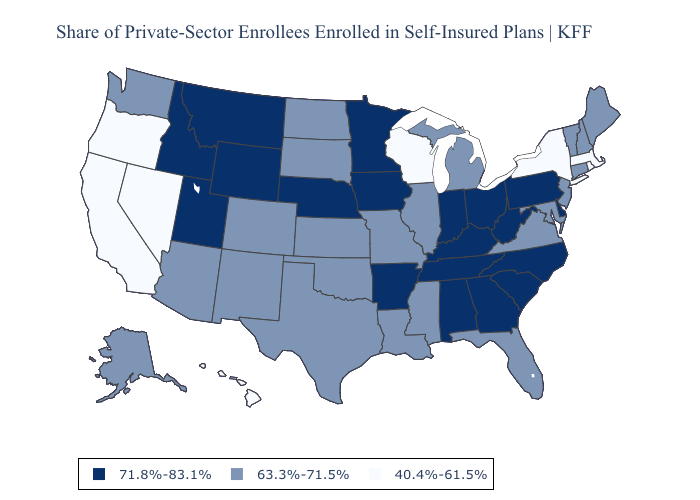What is the value of Michigan?
Keep it brief. 63.3%-71.5%. Name the states that have a value in the range 71.8%-83.1%?
Concise answer only. Alabama, Arkansas, Delaware, Georgia, Idaho, Indiana, Iowa, Kentucky, Minnesota, Montana, Nebraska, North Carolina, Ohio, Pennsylvania, South Carolina, Tennessee, Utah, West Virginia, Wyoming. Among the states that border Idaho , which have the highest value?
Quick response, please. Montana, Utah, Wyoming. Among the states that border Louisiana , does Arkansas have the lowest value?
Give a very brief answer. No. What is the lowest value in the Northeast?
Write a very short answer. 40.4%-61.5%. Name the states that have a value in the range 71.8%-83.1%?
Answer briefly. Alabama, Arkansas, Delaware, Georgia, Idaho, Indiana, Iowa, Kentucky, Minnesota, Montana, Nebraska, North Carolina, Ohio, Pennsylvania, South Carolina, Tennessee, Utah, West Virginia, Wyoming. Among the states that border Missouri , which have the lowest value?
Keep it brief. Illinois, Kansas, Oklahoma. Does West Virginia have the lowest value in the USA?
Be succinct. No. Does the map have missing data?
Short answer required. No. Among the states that border Tennessee , which have the highest value?
Be succinct. Alabama, Arkansas, Georgia, Kentucky, North Carolina. What is the lowest value in the USA?
Answer briefly. 40.4%-61.5%. Is the legend a continuous bar?
Quick response, please. No. What is the value of Missouri?
Concise answer only. 63.3%-71.5%. Name the states that have a value in the range 40.4%-61.5%?
Concise answer only. California, Hawaii, Massachusetts, Nevada, New York, Oregon, Rhode Island, Wisconsin. What is the lowest value in states that border Alabama?
Quick response, please. 63.3%-71.5%. 